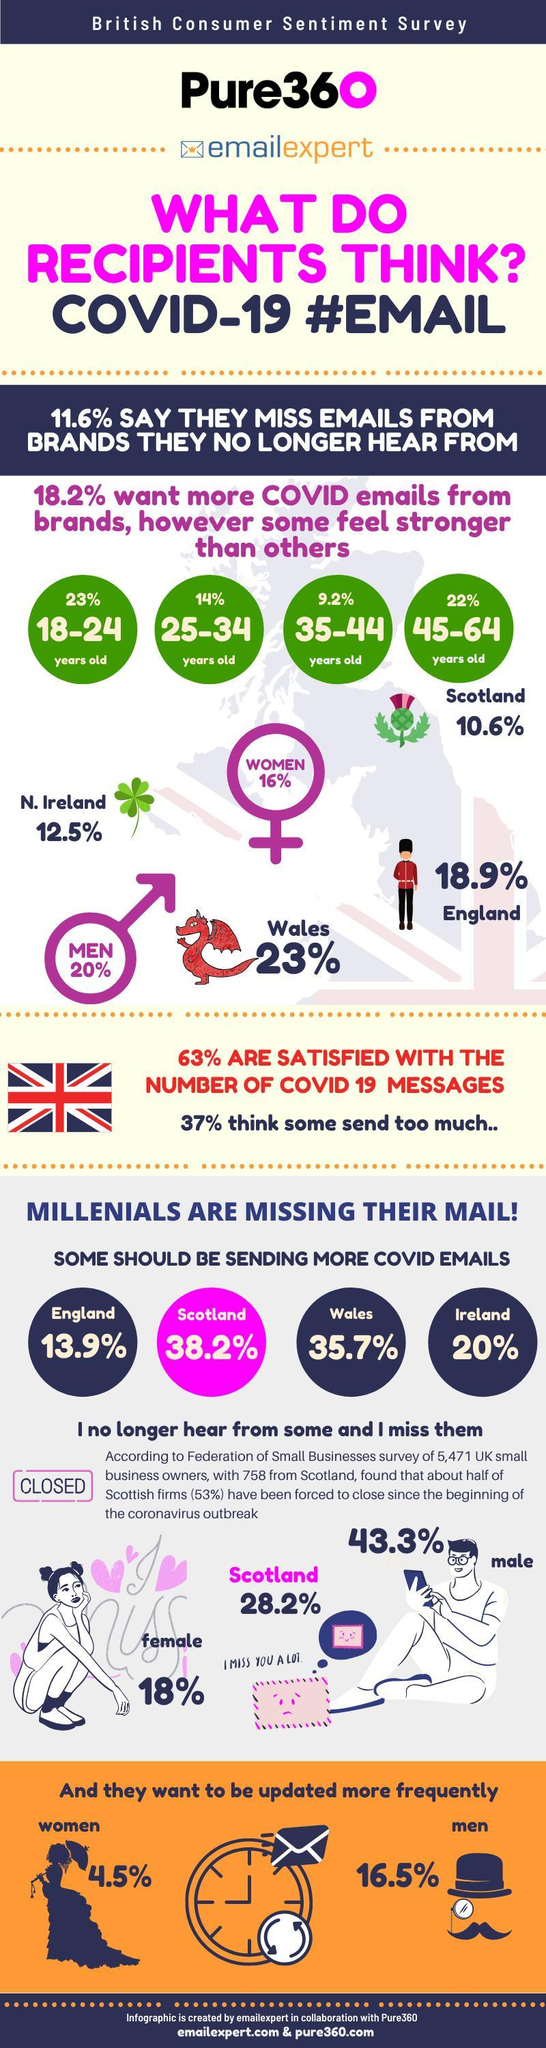which country's flag is shown in the infographic, uk or ireland?
Answer the question with a short phrase. uk 